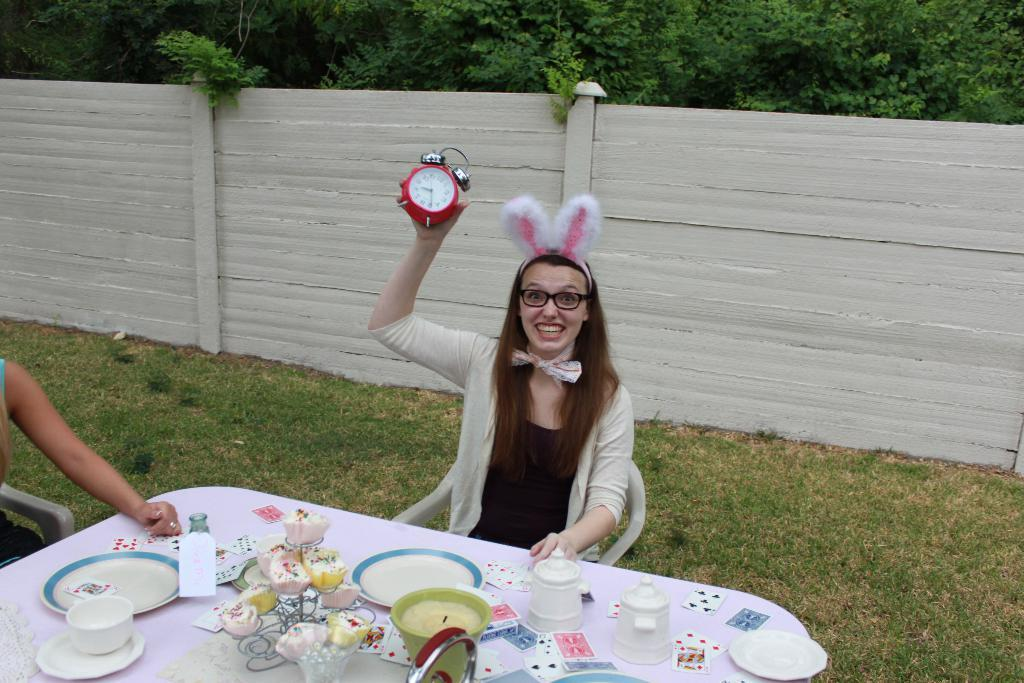Who is the main subject in the image? There is a woman in the image. What is the woman doing in the image? The woman is sitting on a chair and holding a clock in her right hand. What is the woman's facial expression in the image? The woman is smiling in the image. What can be seen in the background of the image? There is a wooden wall and trees visible in the background of the image. What type of skate is the woman wearing in the image? There is no skate present in the image; the woman is sitting on a chair and holding a clock. How does the woman show respect to the clock in the image? The image does not show any indication of the woman showing respect to the clock; she is simply holding it in her right hand. 